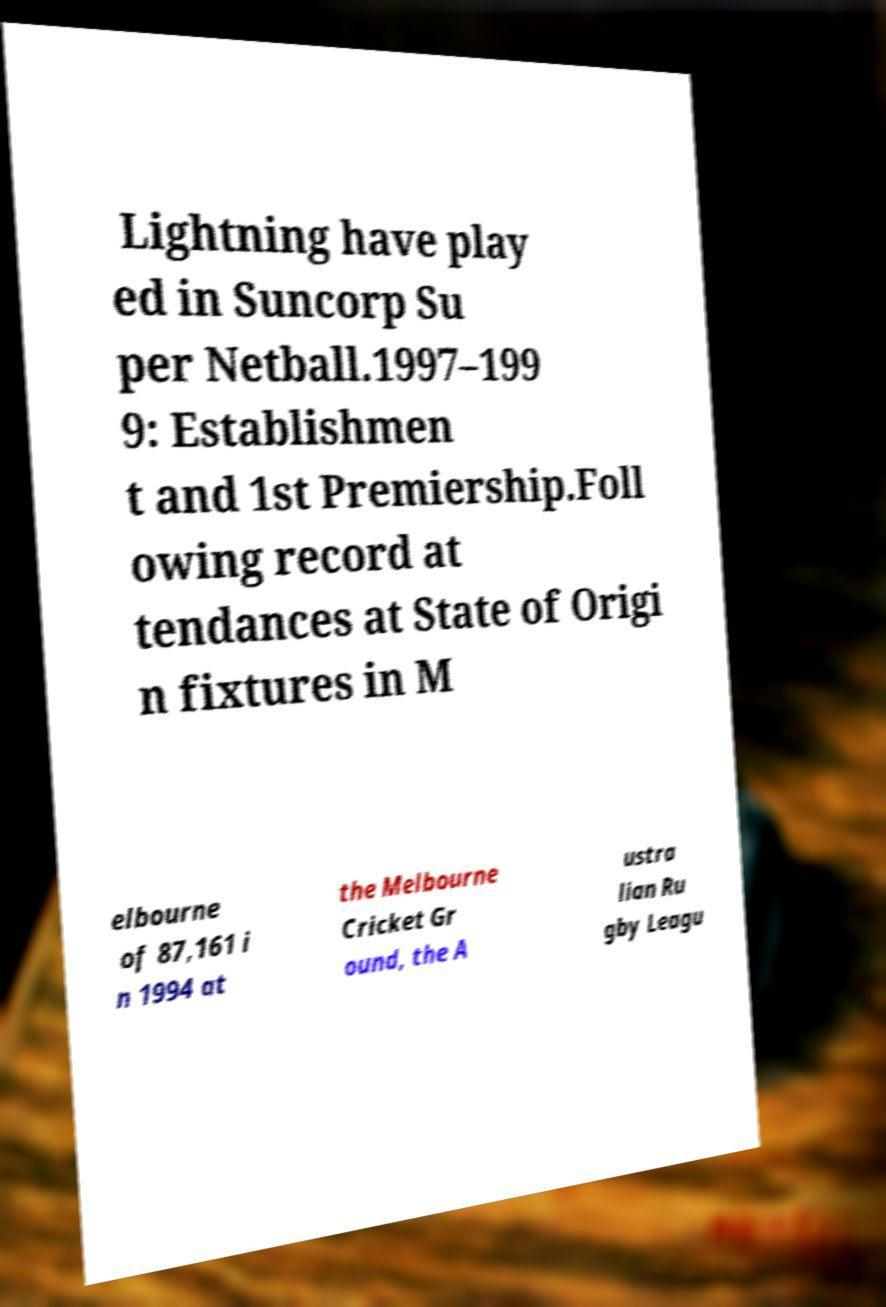Please read and relay the text visible in this image. What does it say? Lightning have play ed in Suncorp Su per Netball.1997–199 9: Establishmen t and 1st Premiership.Foll owing record at tendances at State of Origi n fixtures in M elbourne of 87,161 i n 1994 at the Melbourne Cricket Gr ound, the A ustra lian Ru gby Leagu 